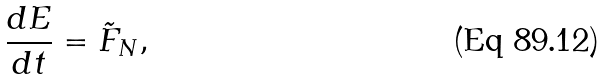Convert formula to latex. <formula><loc_0><loc_0><loc_500><loc_500>\frac { d E } { d t } = \tilde { F } _ { N } ,</formula> 